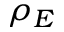<formula> <loc_0><loc_0><loc_500><loc_500>\rho _ { E }</formula> 